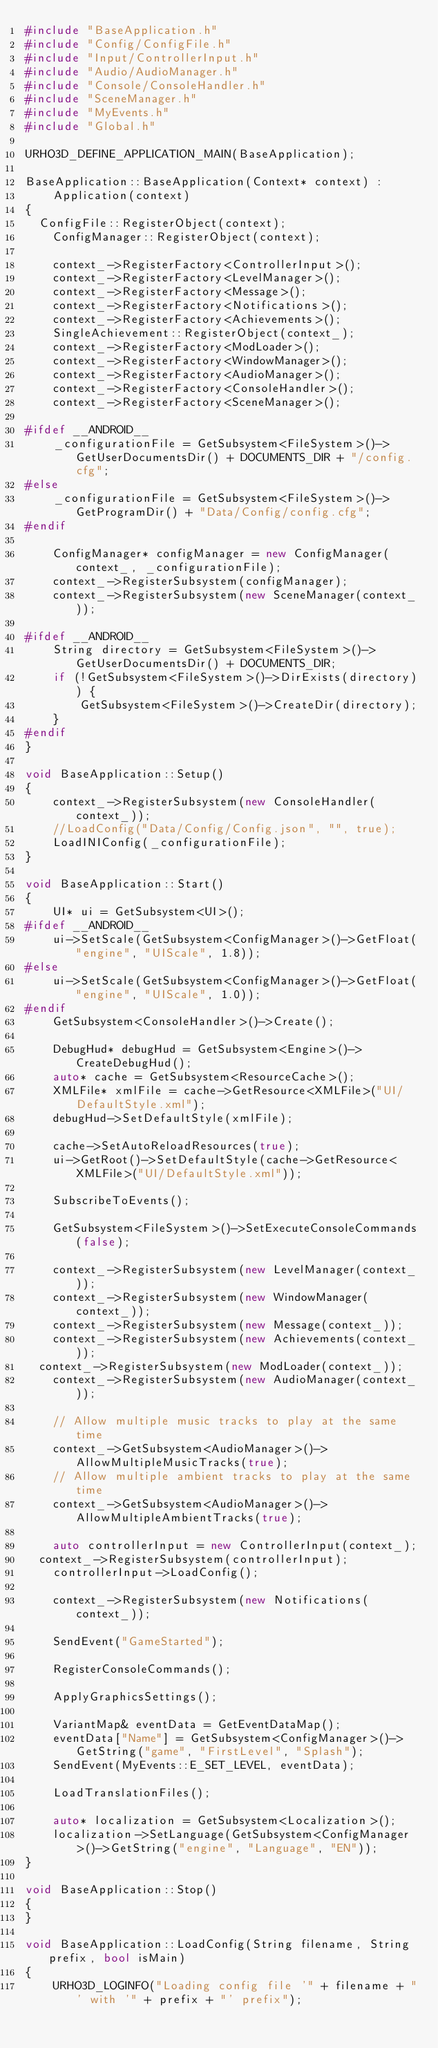<code> <loc_0><loc_0><loc_500><loc_500><_C++_>#include "BaseApplication.h"
#include "Config/ConfigFile.h"
#include "Input/ControllerInput.h"
#include "Audio/AudioManager.h"
#include "Console/ConsoleHandler.h"
#include "SceneManager.h"
#include "MyEvents.h"
#include "Global.h"

URHO3D_DEFINE_APPLICATION_MAIN(BaseApplication);

BaseApplication::BaseApplication(Context* context) :
    Application(context)
{
	ConfigFile::RegisterObject(context);
    ConfigManager::RegisterObject(context);

    context_->RegisterFactory<ControllerInput>();
    context_->RegisterFactory<LevelManager>();
    context_->RegisterFactory<Message>();
    context_->RegisterFactory<Notifications>();
    context_->RegisterFactory<Achievements>();
    SingleAchievement::RegisterObject(context_);
    context_->RegisterFactory<ModLoader>();
    context_->RegisterFactory<WindowManager>();
    context_->RegisterFactory<AudioManager>();
    context_->RegisterFactory<ConsoleHandler>();
    context_->RegisterFactory<SceneManager>();

#ifdef __ANDROID__
    _configurationFile = GetSubsystem<FileSystem>()->GetUserDocumentsDir() + DOCUMENTS_DIR + "/config.cfg";
#else
    _configurationFile = GetSubsystem<FileSystem>()->GetProgramDir() + "Data/Config/config.cfg";
#endif

    ConfigManager* configManager = new ConfigManager(context_, _configurationFile);
    context_->RegisterSubsystem(configManager);
    context_->RegisterSubsystem(new SceneManager(context_));

#ifdef __ANDROID__
    String directory = GetSubsystem<FileSystem>()->GetUserDocumentsDir() + DOCUMENTS_DIR;
    if (!GetSubsystem<FileSystem>()->DirExists(directory)) {
        GetSubsystem<FileSystem>()->CreateDir(directory);
    }
#endif
}

void BaseApplication::Setup()
{
    context_->RegisterSubsystem(new ConsoleHandler(context_));
    //LoadConfig("Data/Config/Config.json", "", true);
    LoadINIConfig(_configurationFile);
}

void BaseApplication::Start()
{
    UI* ui = GetSubsystem<UI>();
#ifdef __ANDROID__
    ui->SetScale(GetSubsystem<ConfigManager>()->GetFloat("engine", "UIScale", 1.8));
#else
    ui->SetScale(GetSubsystem<ConfigManager>()->GetFloat("engine", "UIScale", 1.0));
#endif
    GetSubsystem<ConsoleHandler>()->Create();

    DebugHud* debugHud = GetSubsystem<Engine>()->CreateDebugHud();
    auto* cache = GetSubsystem<ResourceCache>();
    XMLFile* xmlFile = cache->GetResource<XMLFile>("UI/DefaultStyle.xml");
    debugHud->SetDefaultStyle(xmlFile);

    cache->SetAutoReloadResources(true);
    ui->GetRoot()->SetDefaultStyle(cache->GetResource<XMLFile>("UI/DefaultStyle.xml"));

    SubscribeToEvents();

    GetSubsystem<FileSystem>()->SetExecuteConsoleCommands(false);

    context_->RegisterSubsystem(new LevelManager(context_));
    context_->RegisterSubsystem(new WindowManager(context_));
    context_->RegisterSubsystem(new Message(context_));
    context_->RegisterSubsystem(new Achievements(context_));
	context_->RegisterSubsystem(new ModLoader(context_));
    context_->RegisterSubsystem(new AudioManager(context_));

    // Allow multiple music tracks to play at the same time
    context_->GetSubsystem<AudioManager>()->AllowMultipleMusicTracks(true);
    // Allow multiple ambient tracks to play at the same time
    context_->GetSubsystem<AudioManager>()->AllowMultipleAmbientTracks(true);

    auto controllerInput = new ControllerInput(context_);
	context_->RegisterSubsystem(controllerInput);
    controllerInput->LoadConfig();

    context_->RegisterSubsystem(new Notifications(context_));

    SendEvent("GameStarted");

    RegisterConsoleCommands();

    ApplyGraphicsSettings();

    VariantMap& eventData = GetEventDataMap();
    eventData["Name"] = GetSubsystem<ConfigManager>()->GetString("game", "FirstLevel", "Splash");
    SendEvent(MyEvents::E_SET_LEVEL, eventData);

    LoadTranslationFiles();

    auto* localization = GetSubsystem<Localization>();
    localization->SetLanguage(GetSubsystem<ConfigManager>()->GetString("engine", "Language", "EN"));
}

void BaseApplication::Stop()
{
}

void BaseApplication::LoadConfig(String filename, String prefix, bool isMain)
{
    URHO3D_LOGINFO("Loading config file '" + filename + "' with '" + prefix + "' prefix");</code> 